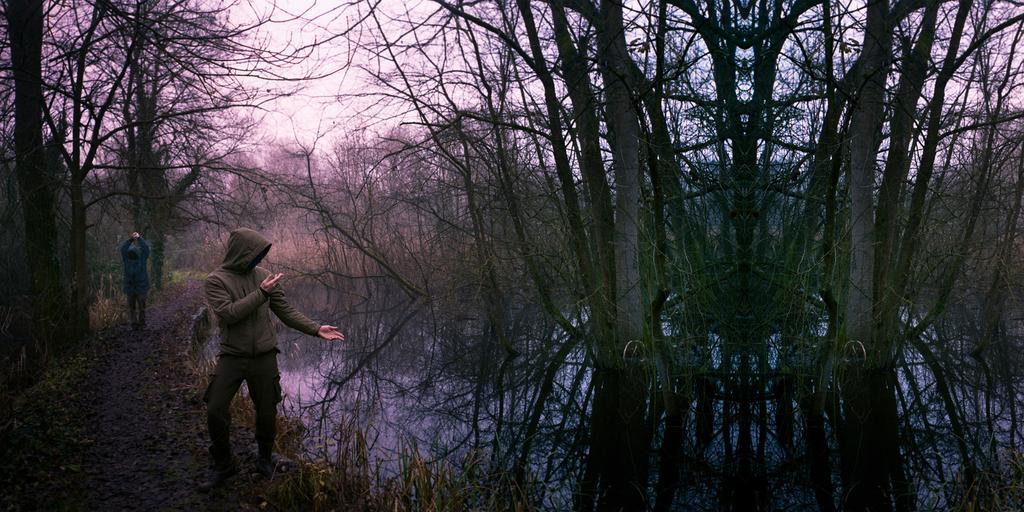Describe this image in one or two sentences. In this picture we can see trees, there are two persons standing on the left side, we can see water in the middle, there is the sky at the top of the picture. 